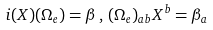<formula> <loc_0><loc_0><loc_500><loc_500>i ( X ) ( \Omega _ { e } ) = \beta \, , \, ( \Omega _ { e } ) _ { a b } X ^ { b } = \beta _ { a }</formula> 